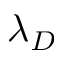<formula> <loc_0><loc_0><loc_500><loc_500>\lambda _ { D }</formula> 